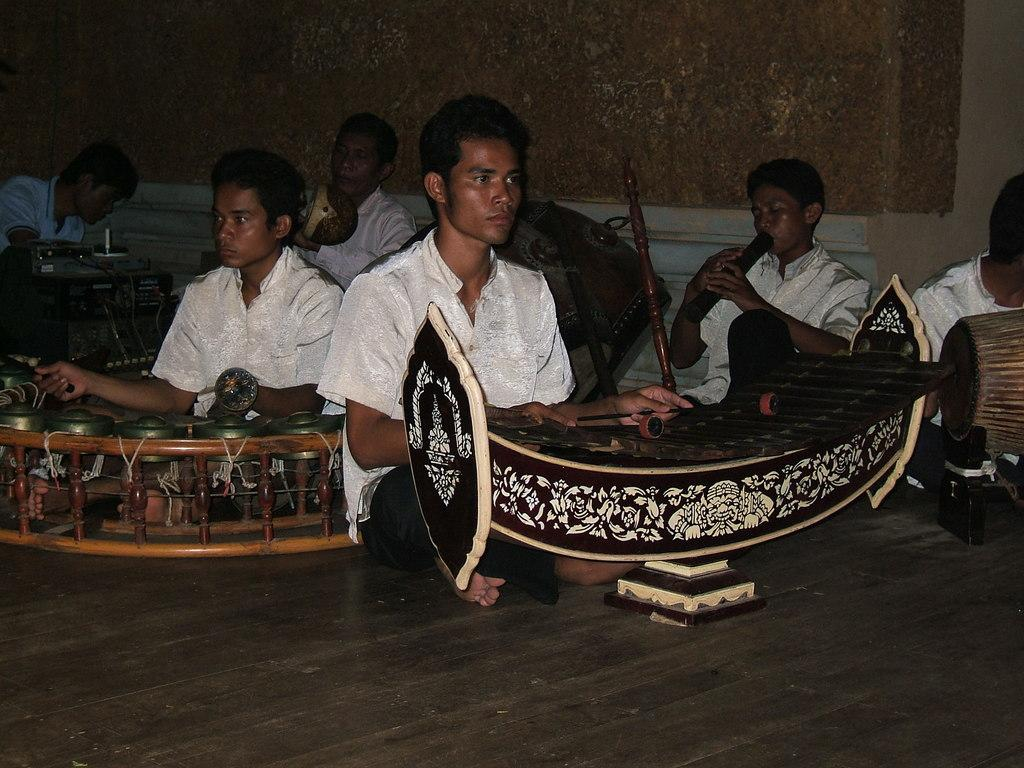What is happening in the image involving a group of people? The people in the image are sitting and playing musical instruments. Can you describe the setting in which the people are playing their instruments? There is a wall in the background of the image, and a floor is visible. What type of activity are the people engaged in? The people are playing musical instruments. What type of wire can be seen connecting the musical instruments in the image? There is no wire connecting the musical instruments visible in the image. What type of sofa is present in the image? There is no sofa present in the image. 